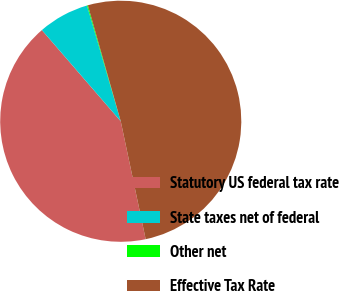Convert chart. <chart><loc_0><loc_0><loc_500><loc_500><pie_chart><fcel>Statutory US federal tax rate<fcel>State taxes net of federal<fcel>Other net<fcel>Effective Tax Rate<nl><fcel>41.97%<fcel>6.83%<fcel>0.12%<fcel>51.08%<nl></chart> 